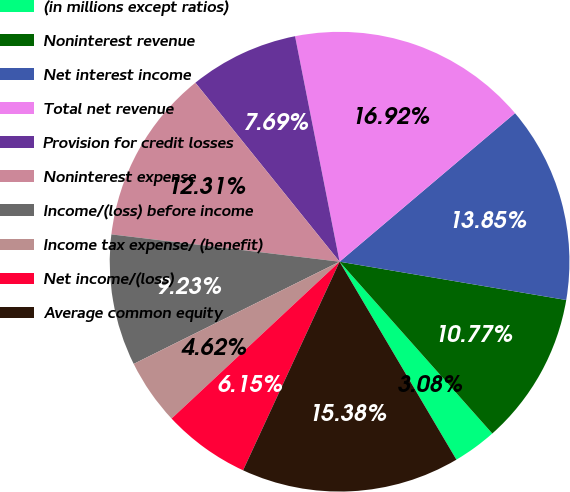Convert chart to OTSL. <chart><loc_0><loc_0><loc_500><loc_500><pie_chart><fcel>(in millions except ratios)<fcel>Noninterest revenue<fcel>Net interest income<fcel>Total net revenue<fcel>Provision for credit losses<fcel>Noninterest expense<fcel>Income/(loss) before income<fcel>Income tax expense/ (benefit)<fcel>Net income/(loss)<fcel>Average common equity<nl><fcel>3.08%<fcel>10.77%<fcel>13.85%<fcel>16.92%<fcel>7.69%<fcel>12.31%<fcel>9.23%<fcel>4.62%<fcel>6.15%<fcel>15.38%<nl></chart> 